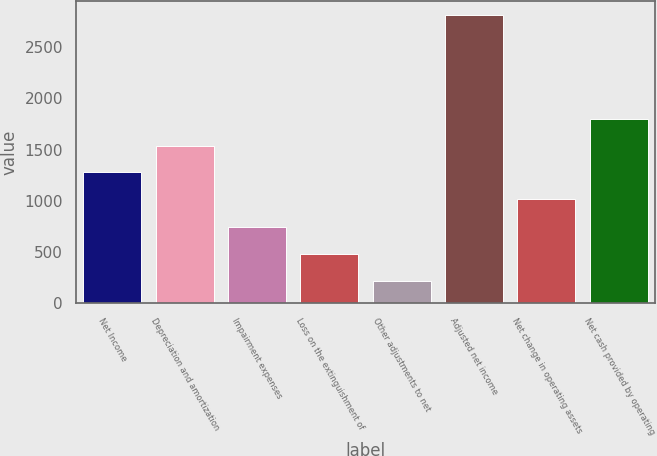<chart> <loc_0><loc_0><loc_500><loc_500><bar_chart><fcel>Net Income<fcel>Depreciation and amortization<fcel>Impairment expenses<fcel>Loss on the extinguishment of<fcel>Other adjustments to net<fcel>Adjusted net income<fcel>Net change in operating assets<fcel>Net cash provided by operating<nl><fcel>1281<fcel>1540<fcel>741<fcel>482<fcel>223<fcel>2813<fcel>1022<fcel>1799<nl></chart> 